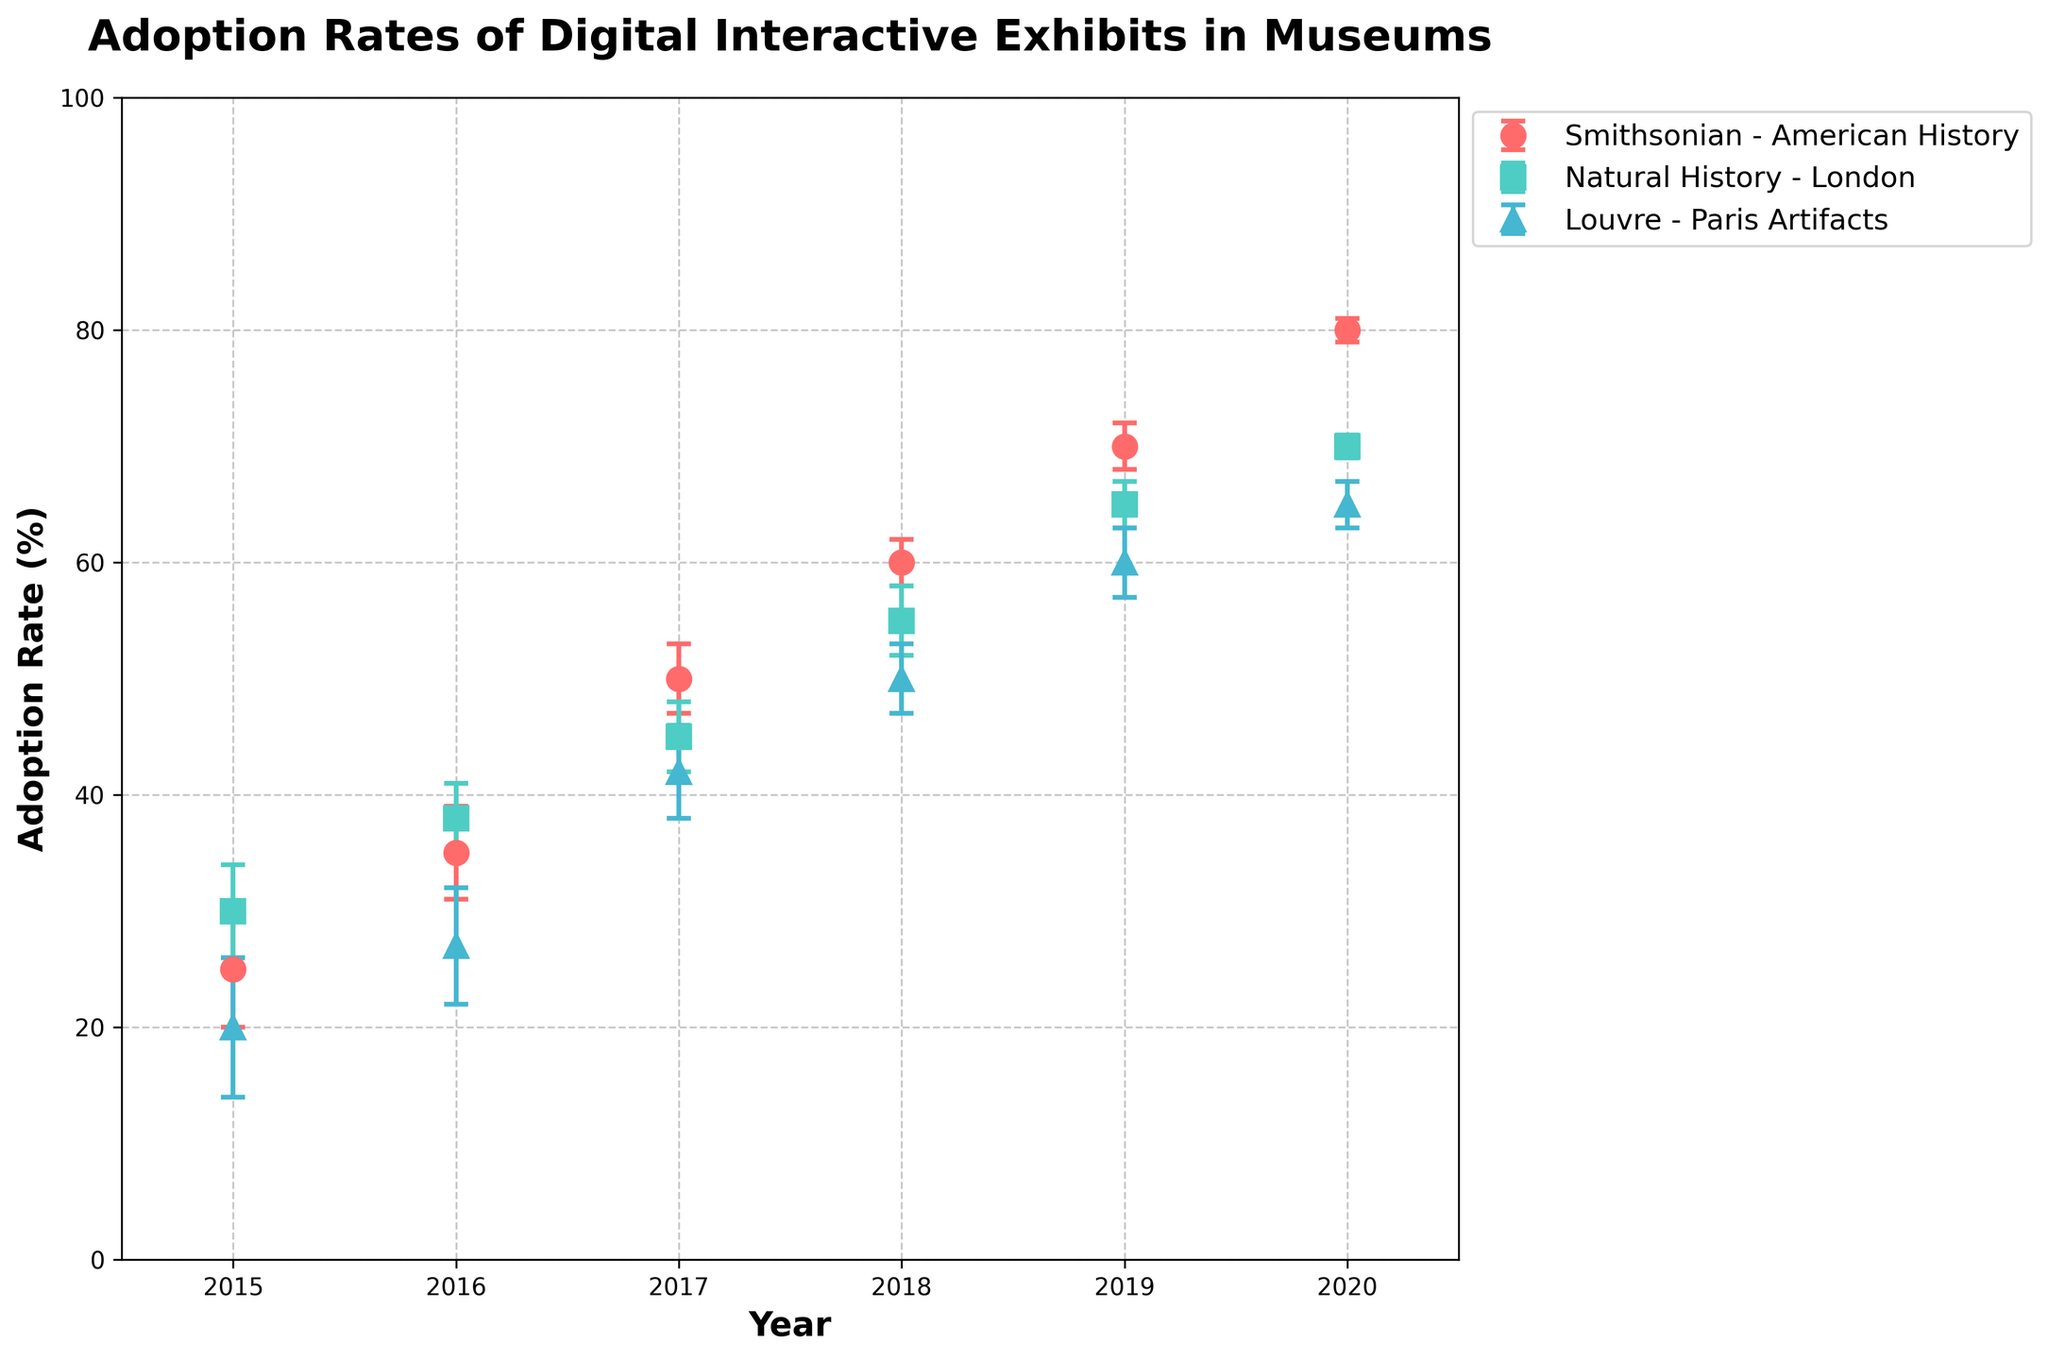What is the title of the figure? The title of a figure is typically placed at the top and describes what the figure is about.
Answer: Adoption Rates of Digital Interactive Exhibits in Museums What years are displayed on the x-axis? The x-axis shows the range of years being displayed in the plot, which are labeled accordingly.
Answer: 2015 to 2020 Which museum had the highest adoption rate in 2020? By looking at the data points for the year 2020, identify the museum with the highest adoption rate on the y-axis.
Answer: Smithsonian - American History What are the colors used to represent each museum? The legend in the figure shows the museums and their corresponding colors.
Answer: Smithsonian - American History (Red), Natural History - London (Green), Louvre - Paris Artifacts (Blue) Describe the trend in adoption rates for the Smithsonian - American History exhibit from 2015 to 2020. Track the data points for Smithsonian - American History over the years and describe whether they are increasing, decreasing, or remaining stable.
Answer: Increasing Which year did the Louvre - Paris Artifacts have its highest adoption rate, and what was the rate? Identify the year with the highest point for the Louvre from the plot and read the adoption rate.
Answer: 2020, 65% How does the adoption rate for the Natural History - London in 2016 compare to its rate in 2019? Locate the adoption rates for Natural History - London in 2016 and 2019 from the plot and compare them.
Answer: 38% in 2016, 65% in 2019 What is the range of adoption rates for the Louvre - Paris Artifacts from 2015 to 2020? Identify the minimum and maximum adoption rates for the Louvre from the plot and calculate the range.
Answer: 20% to 65%, range is 45% Between 2018 and 2020, which museum shows the most significant increase in adoption rate and by how much? Compare the differences in adoption rates for each museum between 2018 and 2020 and identify which one had the largest increase.
Answer: Smithsonian - American History, 20% How do the error bars change over the years for Smithsonian - American History, and what could this imply? Observe the length of the error bars for Smithsonian - American History over the years specifically. If they shorten, it indicates less variability or more precise measurements over time.
Answer: Decrease, implying more precise measurements 